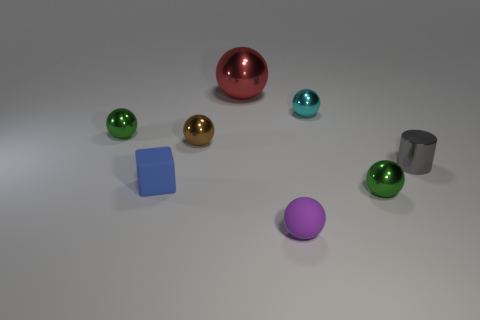Is there any other thing that has the same shape as the blue matte object?
Provide a succinct answer. No. Is there a tiny purple object of the same shape as the tiny blue matte object?
Offer a terse response. No. What is the small cube made of?
Your answer should be compact. Rubber. Are there any blue cubes on the left side of the tiny cyan metallic thing?
Provide a short and direct response. Yes. How many metal cylinders are in front of the gray metal cylinder behind the small blue thing?
Your answer should be compact. 0. There is a blue thing that is the same size as the rubber sphere; what material is it?
Your answer should be very brief. Rubber. How many other things are the same material as the small brown sphere?
Offer a very short reply. 5. There is a large red ball; what number of tiny purple matte spheres are behind it?
Provide a short and direct response. 0. What number of balls are tiny purple rubber objects or big metallic things?
Your answer should be compact. 2. What size is the thing that is left of the small brown metallic thing and in front of the tiny gray metallic thing?
Offer a very short reply. Small. 